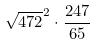<formula> <loc_0><loc_0><loc_500><loc_500>\sqrt { 4 7 2 } ^ { 2 } \cdot \frac { 2 4 7 } { 6 5 }</formula> 